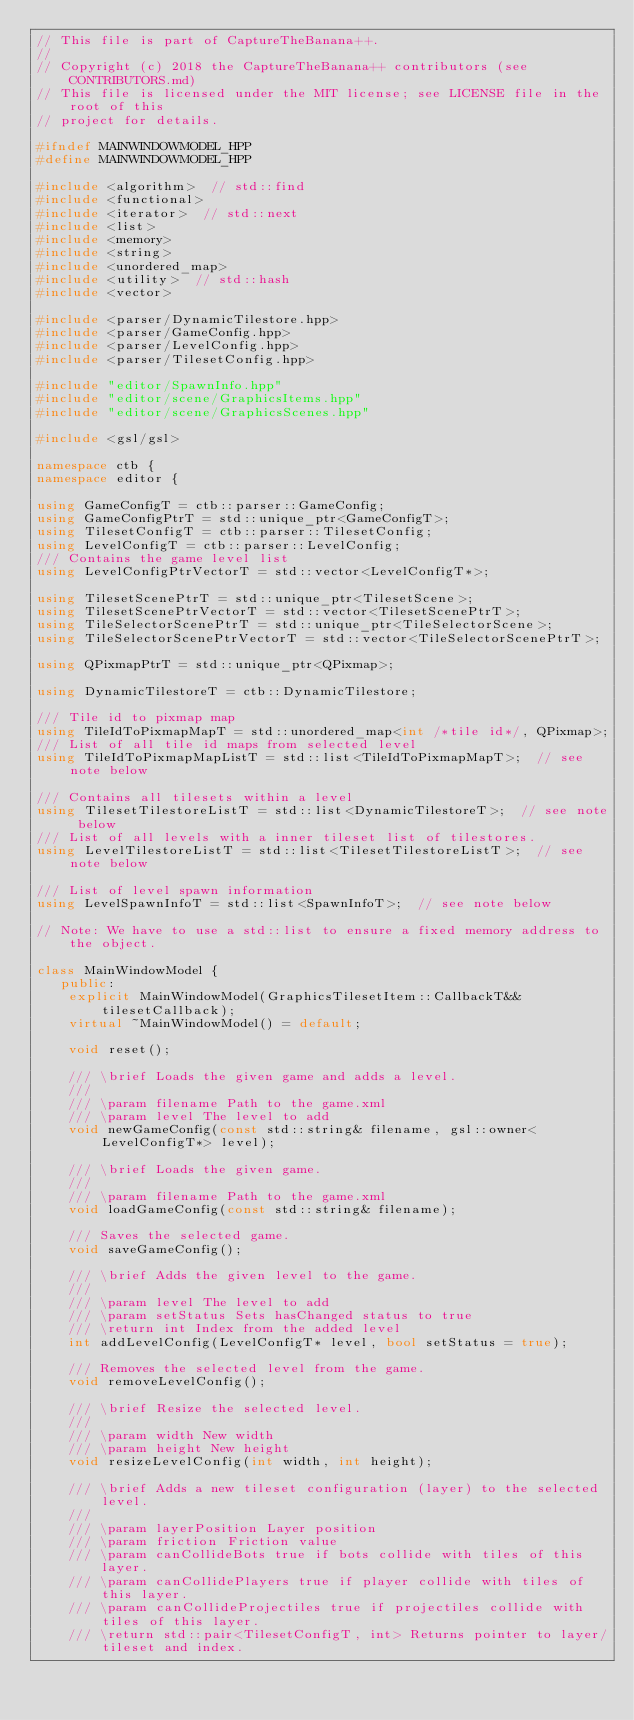Convert code to text. <code><loc_0><loc_0><loc_500><loc_500><_C++_>// This file is part of CaptureTheBanana++.
//
// Copyright (c) 2018 the CaptureTheBanana++ contributors (see CONTRIBUTORS.md)
// This file is licensed under the MIT license; see LICENSE file in the root of this
// project for details.

#ifndef MAINWINDOWMODEL_HPP
#define MAINWINDOWMODEL_HPP

#include <algorithm>  // std::find
#include <functional>
#include <iterator>  // std::next
#include <list>
#include <memory>
#include <string>
#include <unordered_map>
#include <utility>  // std::hash
#include <vector>

#include <parser/DynamicTilestore.hpp>
#include <parser/GameConfig.hpp>
#include <parser/LevelConfig.hpp>
#include <parser/TilesetConfig.hpp>

#include "editor/SpawnInfo.hpp"
#include "editor/scene/GraphicsItems.hpp"
#include "editor/scene/GraphicsScenes.hpp"

#include <gsl/gsl>

namespace ctb {
namespace editor {

using GameConfigT = ctb::parser::GameConfig;
using GameConfigPtrT = std::unique_ptr<GameConfigT>;
using TilesetConfigT = ctb::parser::TilesetConfig;
using LevelConfigT = ctb::parser::LevelConfig;
/// Contains the game level list
using LevelConfigPtrVectorT = std::vector<LevelConfigT*>;

using TilesetScenePtrT = std::unique_ptr<TilesetScene>;
using TilesetScenePtrVectorT = std::vector<TilesetScenePtrT>;
using TileSelectorScenePtrT = std::unique_ptr<TileSelectorScene>;
using TileSelectorScenePtrVectorT = std::vector<TileSelectorScenePtrT>;

using QPixmapPtrT = std::unique_ptr<QPixmap>;

using DynamicTilestoreT = ctb::DynamicTilestore;

/// Tile id to pixmap map
using TileIdToPixmapMapT = std::unordered_map<int /*tile id*/, QPixmap>;
/// List of all tile id maps from selected level
using TileIdToPixmapMapListT = std::list<TileIdToPixmapMapT>;  // see note below

/// Contains all tilesets within a level
using TilesetTilestoreListT = std::list<DynamicTilestoreT>;  // see note below
/// List of all levels with a inner tileset list of tilestores.
using LevelTilestoreListT = std::list<TilesetTilestoreListT>;  // see note below

/// List of level spawn information
using LevelSpawnInfoT = std::list<SpawnInfoT>;  // see note below

// Note: We have to use a std::list to ensure a fixed memory address to the object.

class MainWindowModel {
   public:
    explicit MainWindowModel(GraphicsTilesetItem::CallbackT&& tilesetCallback);
    virtual ~MainWindowModel() = default;

    void reset();

    /// \brief Loads the given game and adds a level.
    ///
    /// \param filename Path to the game.xml
    /// \param level The level to add
    void newGameConfig(const std::string& filename, gsl::owner<LevelConfigT*> level);

    /// \brief Loads the given game.
    ///
    /// \param filename Path to the game.xml
    void loadGameConfig(const std::string& filename);

    /// Saves the selected game.
    void saveGameConfig();

    /// \brief Adds the given level to the game.
    ///
    /// \param level The level to add
    /// \param setStatus Sets hasChanged status to true
    /// \return int Index from the added level
    int addLevelConfig(LevelConfigT* level, bool setStatus = true);

    /// Removes the selected level from the game.
    void removeLevelConfig();

    /// \brief Resize the selected level.
    ///
    /// \param width New width
    /// \param height New height
    void resizeLevelConfig(int width, int height);

    /// \brief Adds a new tileset configuration (layer) to the selected level.
    ///
    /// \param layerPosition Layer position
    /// \param friction Friction value
    /// \param canCollideBots true if bots collide with tiles of this layer.
    /// \param canCollidePlayers true if player collide with tiles of this layer.
    /// \param canCollideProjectiles true if projectiles collide with tiles of this layer.
    /// \return std::pair<TilesetConfigT, int> Returns pointer to layer/tileset and index.</code> 